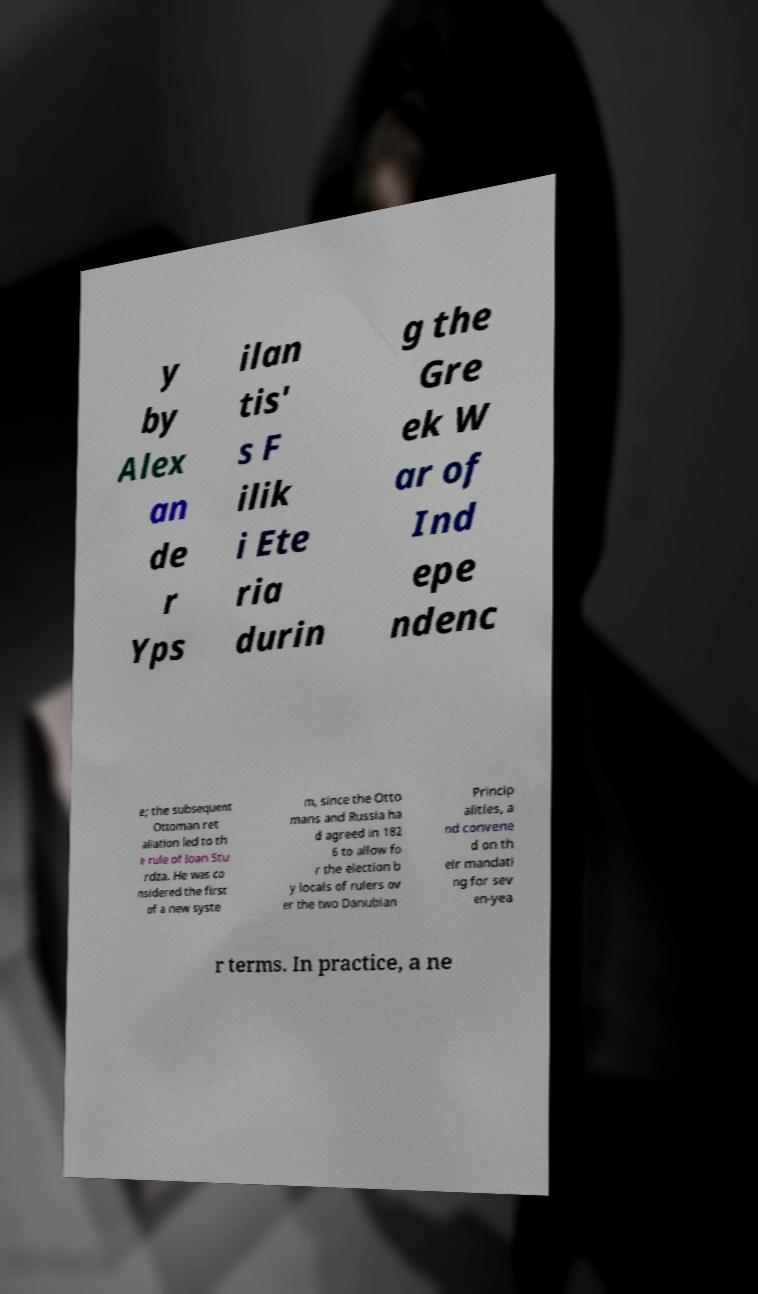Could you extract and type out the text from this image? y by Alex an de r Yps ilan tis' s F ilik i Ete ria durin g the Gre ek W ar of Ind epe ndenc e; the subsequent Ottoman ret aliation led to th e rule of Ioan Stu rdza. He was co nsidered the first of a new syste m, since the Otto mans and Russia ha d agreed in 182 6 to allow fo r the election b y locals of rulers ov er the two Danubian Princip alities, a nd convene d on th eir mandati ng for sev en-yea r terms. In practice, a ne 